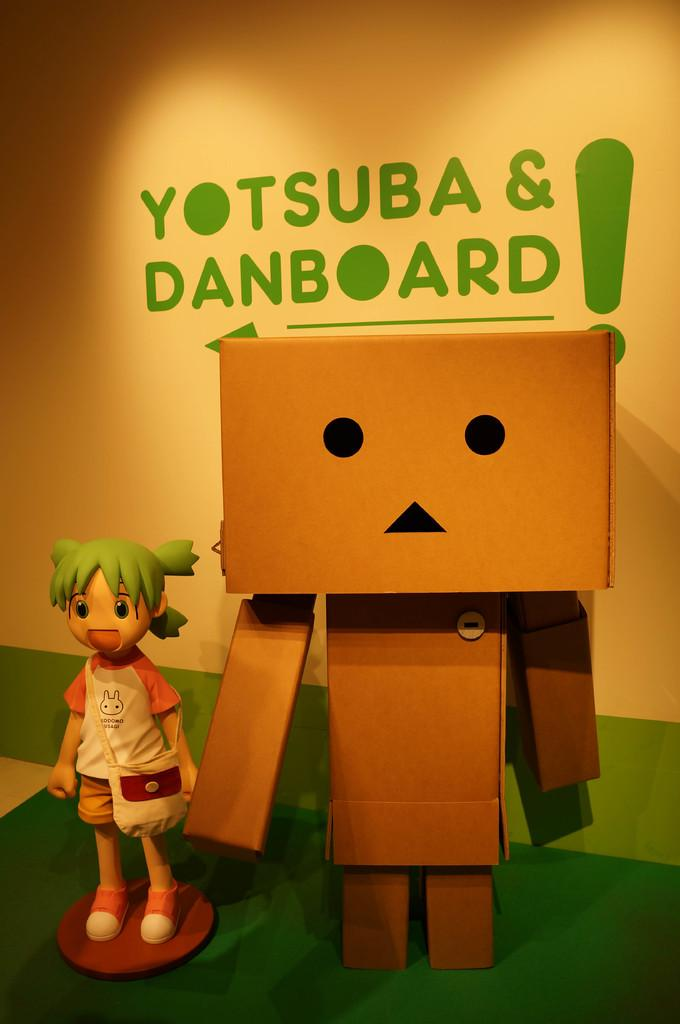What type of toys are present in the image? There are toys of a person in the image. What else can be seen in the image besides the toys? There are other objects in the image. What is the color of the surface on which the toys and objects are placed? The objects are on a green color surface. What is visible in the background of the image? There is a wall in the background of the image. What is written on the wall, and what is its color? Something is written in green color on the wall. How far can the person toy jump in the image? There is no indication of the person toy jumping in the image, so it cannot be determined. 